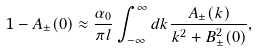Convert formula to latex. <formula><loc_0><loc_0><loc_500><loc_500>1 - A _ { \pm } ( 0 ) \approx \frac { \alpha _ { 0 } } { \pi l } \int _ { - \infty } ^ { \infty } d k \frac { A _ { \pm } ( k ) } { k ^ { 2 } + B _ { \pm } ^ { 2 } ( 0 ) } ,</formula> 